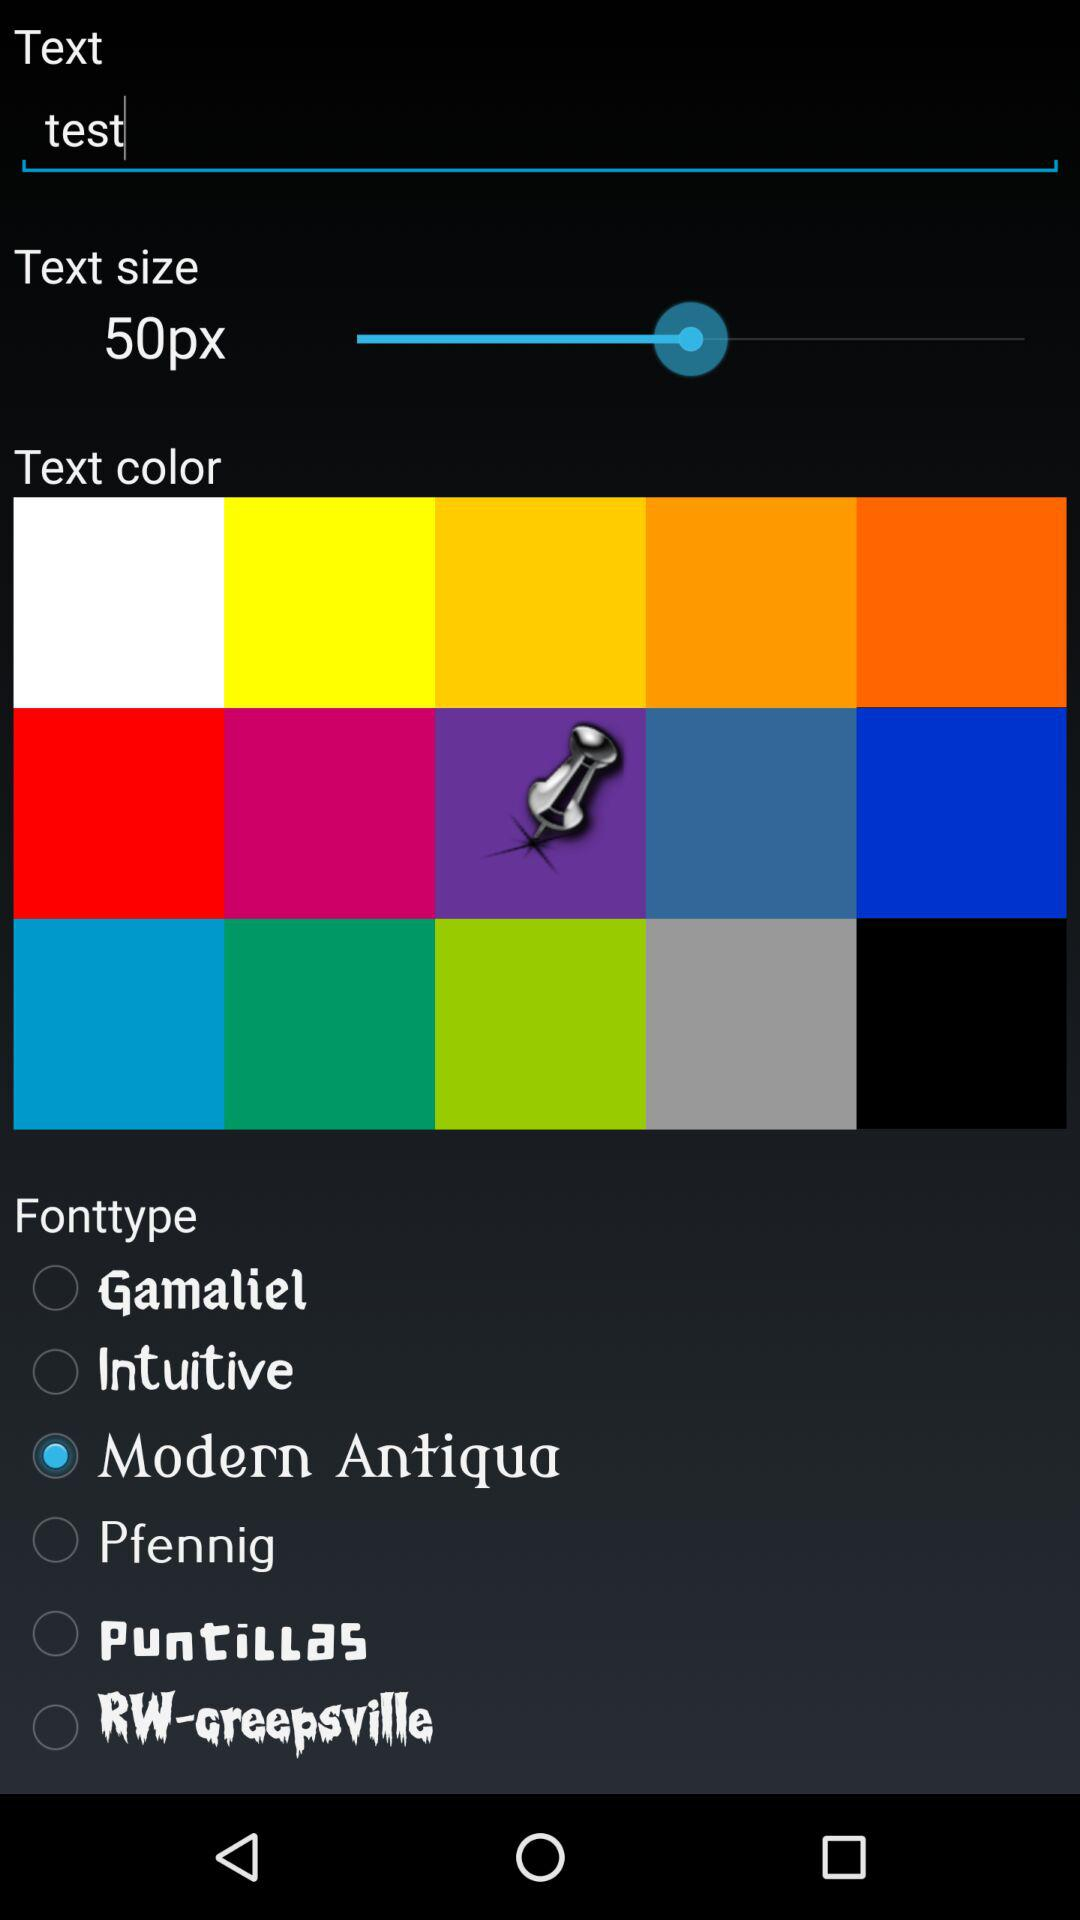What is the text size? The text size is 50 px. 